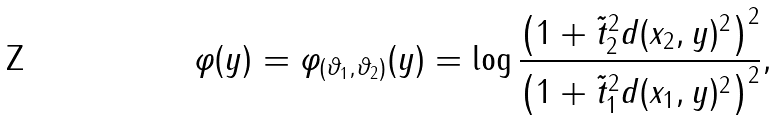<formula> <loc_0><loc_0><loc_500><loc_500>\varphi ( y ) = \varphi _ { ( \vartheta _ { 1 } , \vartheta _ { 2 } ) } ( y ) = \log \frac { \left ( 1 + \tilde { t } _ { 2 } ^ { 2 } d ( x _ { 2 } , y ) ^ { 2 } \right ) ^ { 2 } } { \left ( 1 + \tilde { t } _ { 1 } ^ { 2 } d ( x _ { 1 } , y ) ^ { 2 } \right ) ^ { 2 } } ,</formula> 